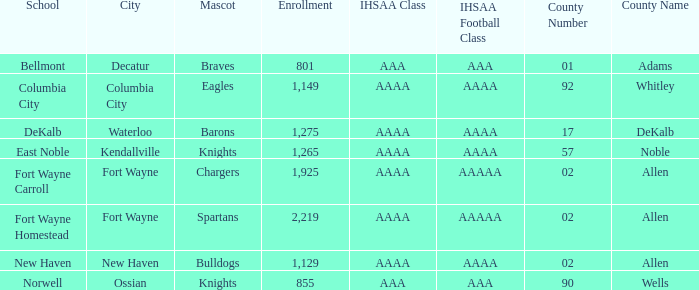What school has a mascot of the spartans with an AAAA IHSAA class and more than 1,275 enrolled? Fort Wayne Homestead. 